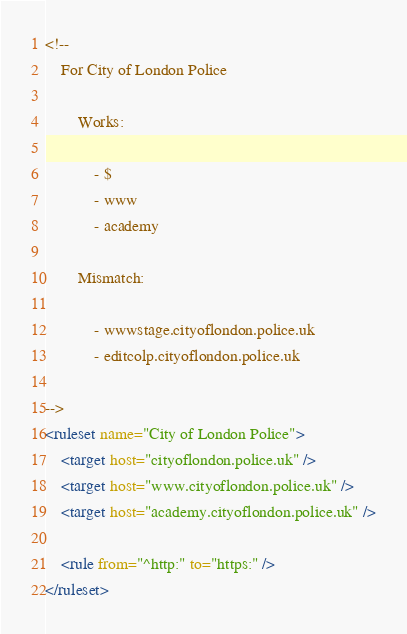Convert code to text. <code><loc_0><loc_0><loc_500><loc_500><_XML_><!--
	For City of London Police

		Works:

			- $
			- www
			- academy

		Mismatch:

			- wwwstage.cityoflondon.police.uk
			- editcolp.cityoflondon.police.uk

-->
<ruleset name="City of London Police">
	<target host="cityoflondon.police.uk" />
	<target host="www.cityoflondon.police.uk" />
	<target host="academy.cityoflondon.police.uk" />

	<rule from="^http:" to="https:" />
</ruleset>
</code> 